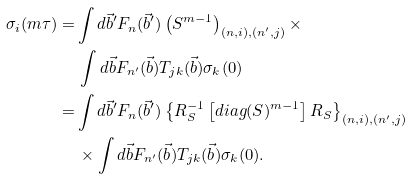<formula> <loc_0><loc_0><loc_500><loc_500>\sigma _ { i } ( m \tau ) = & \int d \vec { b } ^ { \prime } F _ { n } ( \vec { b } ^ { \prime } ) \left ( S ^ { m - 1 } \right ) _ { \left ( n , i \right ) , \left ( n ^ { \prime } , j \right ) } \times \\ \, & \, \int d \vec { b } F _ { n ^ { \prime } } ( \vec { b } ) T _ { j k } ( \vec { b } ) \sigma _ { k } ( 0 ) \\ \, = & \int d \vec { b } ^ { \prime } F _ { n } ( \vec { b } ^ { \prime } ) \left \{ R _ { S } ^ { - 1 } \left [ d i a g ( S ) ^ { m - 1 } \right ] R _ { S } \right \} _ { \left ( n , i \right ) , \left ( n ^ { \prime } , j \right ) } \\ \, & \, \times \int d \vec { b } F _ { n ^ { \prime } } ( \vec { b } ) T _ { j k } ( \vec { b } ) \sigma _ { k } ( 0 ) .</formula> 